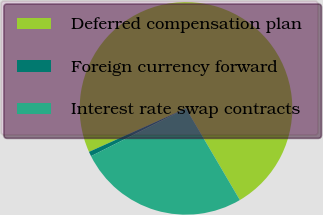Convert chart. <chart><loc_0><loc_0><loc_500><loc_500><pie_chart><fcel>Deferred compensation plan<fcel>Foreign currency forward<fcel>Interest rate swap contracts<nl><fcel>73.25%<fcel>0.71%<fcel>26.04%<nl></chart> 